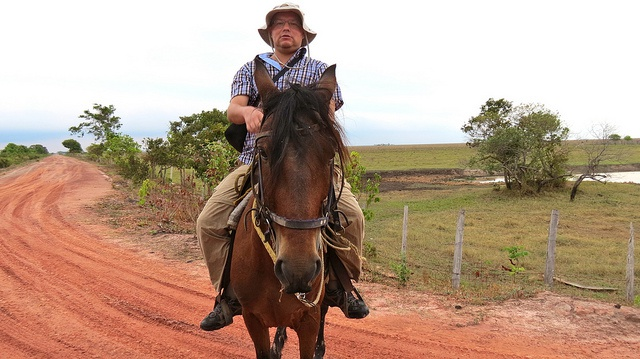Describe the objects in this image and their specific colors. I can see horse in white, maroon, black, and gray tones, people in white, black, maroon, and brown tones, and backpack in white, black, olive, maroon, and gray tones in this image. 